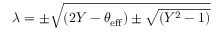<formula> <loc_0><loc_0><loc_500><loc_500>\lambda = \pm \sqrt { ( 2 Y - \theta _ { e f f } ) \pm \sqrt { ( Y ^ { 2 } - 1 ) } }</formula> 